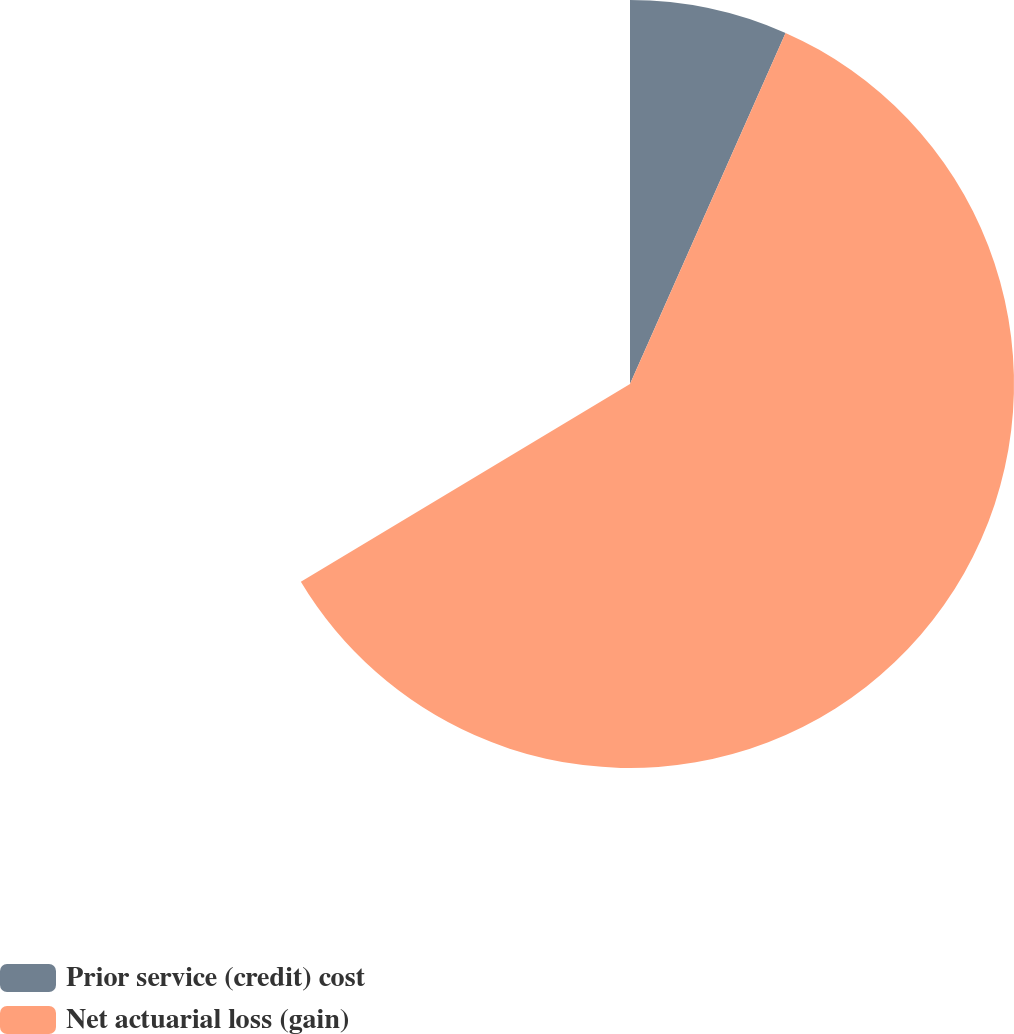<chart> <loc_0><loc_0><loc_500><loc_500><pie_chart><fcel>Prior service (credit) cost<fcel>Net actuarial loss (gain)<nl><fcel>10.0%<fcel>90.0%<nl></chart> 